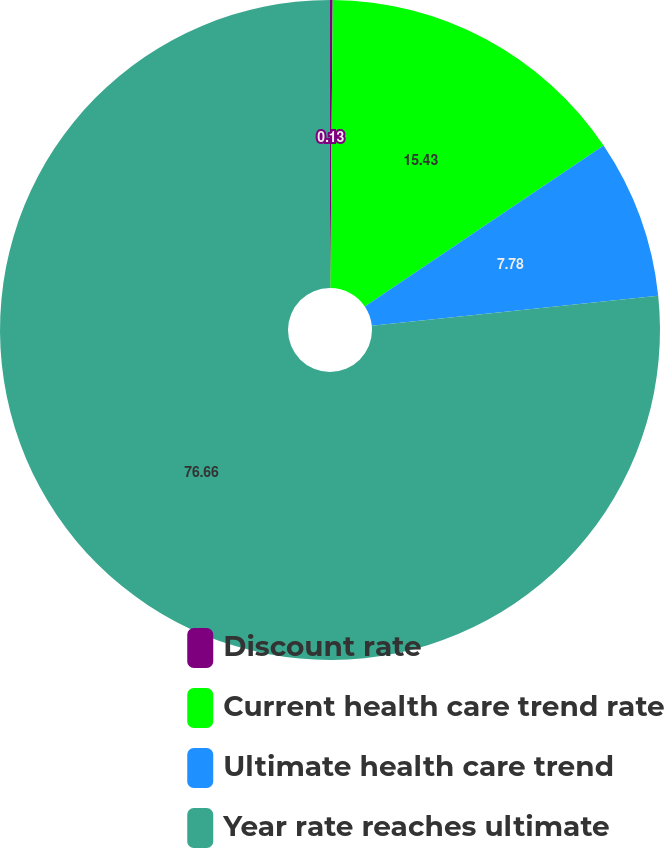Convert chart. <chart><loc_0><loc_0><loc_500><loc_500><pie_chart><fcel>Discount rate<fcel>Current health care trend rate<fcel>Ultimate health care trend<fcel>Year rate reaches ultimate<nl><fcel>0.13%<fcel>15.43%<fcel>7.78%<fcel>76.66%<nl></chart> 